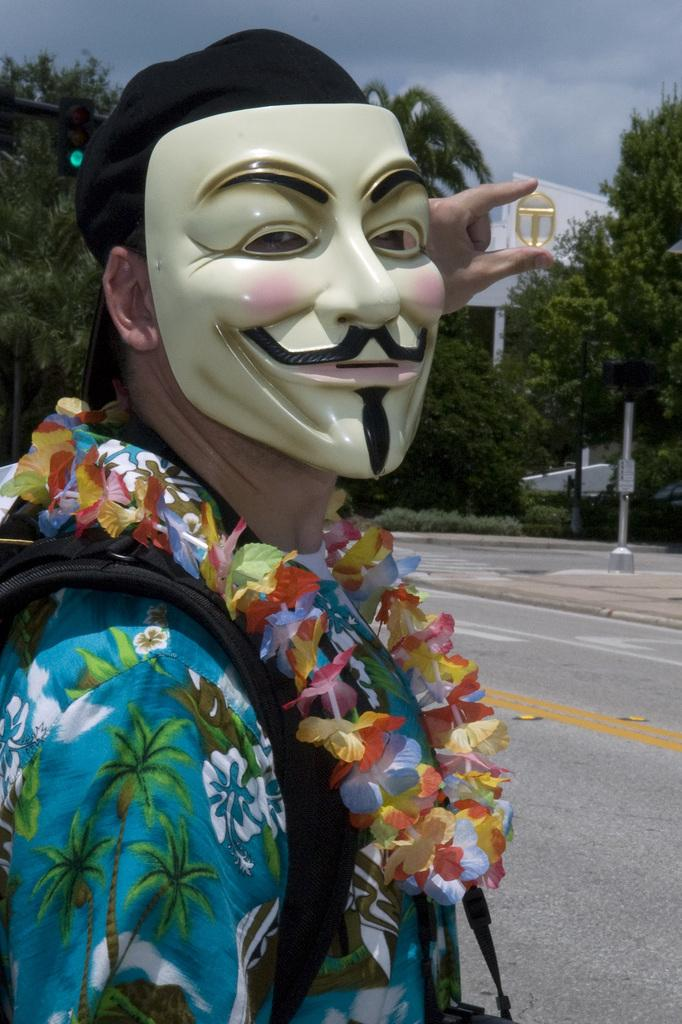What is the main subject of the image? There is a person in the image. Can you describe the person's attire? The person is wearing clothes and a mask. What can be seen in the middle of the image? There is a building and trees in the middle of the image. What is visible at the top of the image? The sky is visible at the top of the image. What caption would best describe the person's emotions in the image? There is no caption provided with the image, so it is impossible to determine the person's emotions or suggest a caption. 